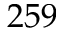<formula> <loc_0><loc_0><loc_500><loc_500>2 5 9</formula> 